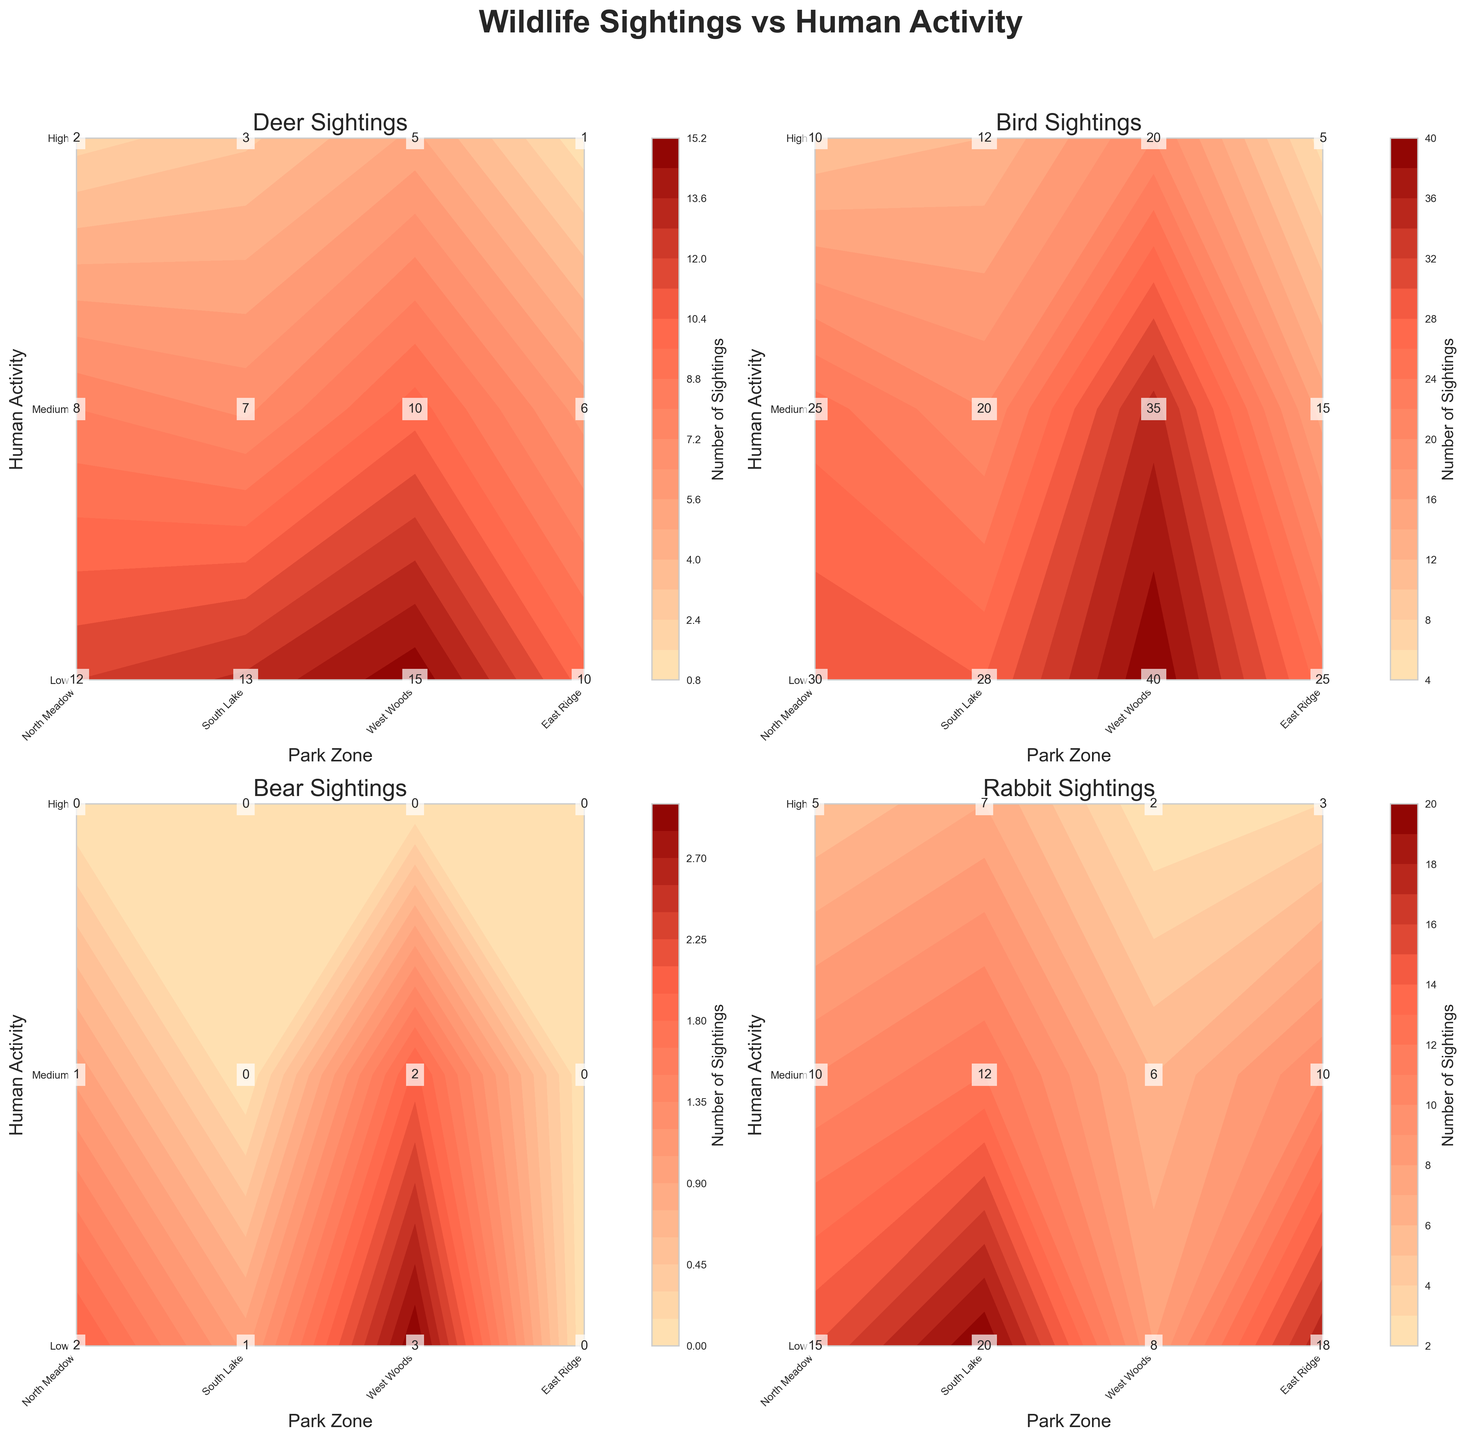What is the title of the figure? The figure's title is displayed at the top of the plot.
Answer: Wildlife Sightings vs Human Activity Which park zone has the highest bear sightings when human activity is low? Look at the "Bear Sightings" subplot and identify the park zone with the highest value on the low human activity row.
Answer: West Woods How does the number of bird sightings in South Lake change as human activity increases? Trace the "Bird Sightings" subplot and follow the values for South Lake from low to high human activity.
Answer: Decreases Which animal sightings show the most drastic decline from medium to high human activity across all park zones? Compare the difference in sightings from medium to high human activity for each animal in all subplots and identify the largest decline.
Answer: Deer How many deer sightings occur in East Ridge with medium human activity? In the "Deer Sightings" subplot, locate East Ridge on the x-axis and medium on the y-axis, and read the value.
Answer: 6 What is the total number of rabbit sightings in North Meadow across all human activity levels? Sum the rabbit sighting values for North Meadow across low, medium, and high human activity from the "Rabbit Sightings" subplot.
Answer: 30 Compare the bird sightings in West Woods from low to medium human activity. Which has more sightings? Look at the "Bird Sightings" subplot and compare the values for West Woods at low and medium human activity.
Answer: Low Which animal has zero sightings in the highest number of park zones when human activity is high? Check each subplot for high human activity and count the number of park zones with zero sightings for each animal.
Answer: Bear In which park zone do deer sightings decrease the most between low and high human activity? Identify the park zone with the largest decrease in deer sightings from low to high human activity in the "Deer Sightings" subplot.
Answer: East Ridge What is the average number of rabbit sightings in East Ridge across all human activity levels? Sum the rabbit sighting values for East Ridge across low, medium, and high human activity in the "Rabbit Sightings" subplot, then divide by 3.
Answer: 10.33 